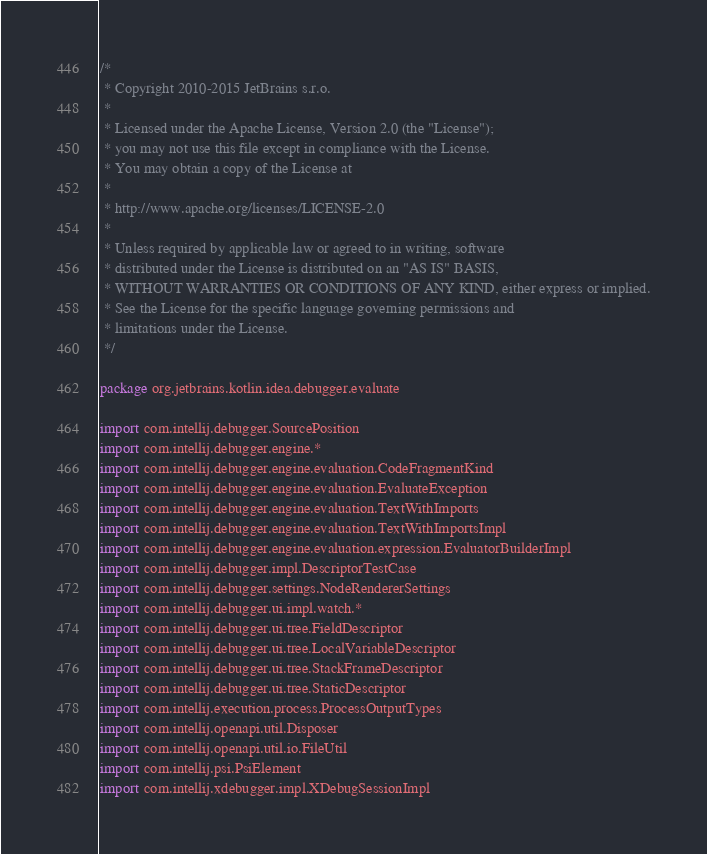Convert code to text. <code><loc_0><loc_0><loc_500><loc_500><_Kotlin_>/*
 * Copyright 2010-2015 JetBrains s.r.o.
 *
 * Licensed under the Apache License, Version 2.0 (the "License");
 * you may not use this file except in compliance with the License.
 * You may obtain a copy of the License at
 *
 * http://www.apache.org/licenses/LICENSE-2.0
 *
 * Unless required by applicable law or agreed to in writing, software
 * distributed under the License is distributed on an "AS IS" BASIS,
 * WITHOUT WARRANTIES OR CONDITIONS OF ANY KIND, either express or implied.
 * See the License for the specific language governing permissions and
 * limitations under the License.
 */

package org.jetbrains.kotlin.idea.debugger.evaluate

import com.intellij.debugger.SourcePosition
import com.intellij.debugger.engine.*
import com.intellij.debugger.engine.evaluation.CodeFragmentKind
import com.intellij.debugger.engine.evaluation.EvaluateException
import com.intellij.debugger.engine.evaluation.TextWithImports
import com.intellij.debugger.engine.evaluation.TextWithImportsImpl
import com.intellij.debugger.engine.evaluation.expression.EvaluatorBuilderImpl
import com.intellij.debugger.impl.DescriptorTestCase
import com.intellij.debugger.settings.NodeRendererSettings
import com.intellij.debugger.ui.impl.watch.*
import com.intellij.debugger.ui.tree.FieldDescriptor
import com.intellij.debugger.ui.tree.LocalVariableDescriptor
import com.intellij.debugger.ui.tree.StackFrameDescriptor
import com.intellij.debugger.ui.tree.StaticDescriptor
import com.intellij.execution.process.ProcessOutputTypes
import com.intellij.openapi.util.Disposer
import com.intellij.openapi.util.io.FileUtil
import com.intellij.psi.PsiElement
import com.intellij.xdebugger.impl.XDebugSessionImpl</code> 